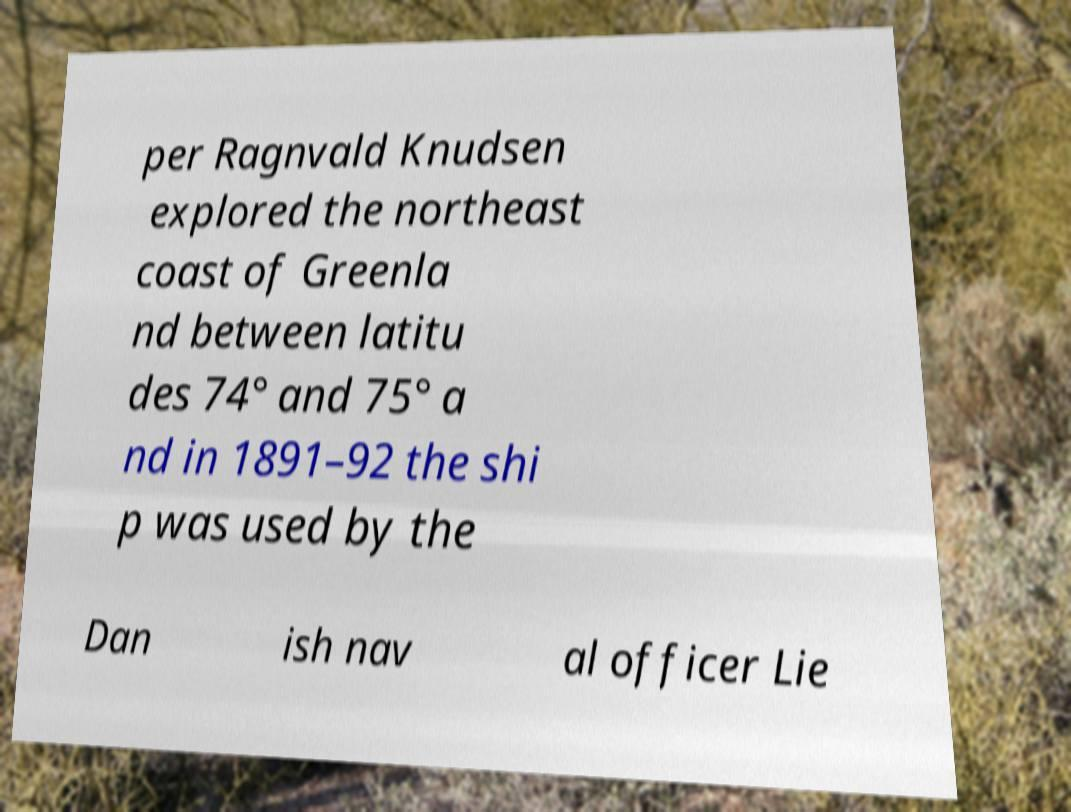Can you accurately transcribe the text from the provided image for me? per Ragnvald Knudsen explored the northeast coast of Greenla nd between latitu des 74° and 75° a nd in 1891–92 the shi p was used by the Dan ish nav al officer Lie 